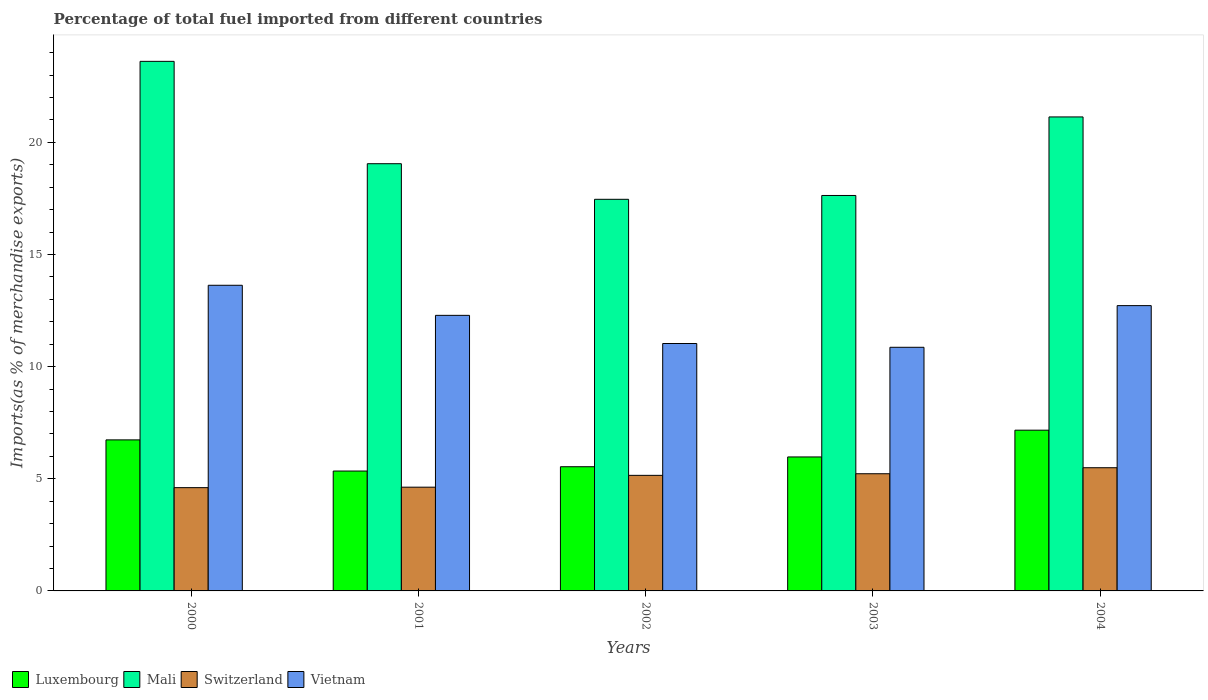How many different coloured bars are there?
Your response must be concise. 4. How many bars are there on the 1st tick from the left?
Give a very brief answer. 4. How many bars are there on the 3rd tick from the right?
Offer a very short reply. 4. What is the label of the 3rd group of bars from the left?
Your answer should be very brief. 2002. What is the percentage of imports to different countries in Vietnam in 2000?
Your answer should be very brief. 13.63. Across all years, what is the maximum percentage of imports to different countries in Vietnam?
Offer a terse response. 13.63. Across all years, what is the minimum percentage of imports to different countries in Vietnam?
Your answer should be compact. 10.86. What is the total percentage of imports to different countries in Switzerland in the graph?
Offer a very short reply. 25.1. What is the difference between the percentage of imports to different countries in Vietnam in 2001 and that in 2004?
Offer a terse response. -0.43. What is the difference between the percentage of imports to different countries in Switzerland in 2000 and the percentage of imports to different countries in Vietnam in 2001?
Ensure brevity in your answer.  -7.68. What is the average percentage of imports to different countries in Switzerland per year?
Provide a succinct answer. 5.02. In the year 2001, what is the difference between the percentage of imports to different countries in Vietnam and percentage of imports to different countries in Switzerland?
Provide a succinct answer. 7.66. What is the ratio of the percentage of imports to different countries in Vietnam in 2002 to that in 2004?
Make the answer very short. 0.87. Is the difference between the percentage of imports to different countries in Vietnam in 2002 and 2003 greater than the difference between the percentage of imports to different countries in Switzerland in 2002 and 2003?
Ensure brevity in your answer.  Yes. What is the difference between the highest and the second highest percentage of imports to different countries in Luxembourg?
Keep it short and to the point. 0.43. What is the difference between the highest and the lowest percentage of imports to different countries in Mali?
Give a very brief answer. 6.15. Is the sum of the percentage of imports to different countries in Switzerland in 2002 and 2003 greater than the maximum percentage of imports to different countries in Mali across all years?
Give a very brief answer. No. Is it the case that in every year, the sum of the percentage of imports to different countries in Vietnam and percentage of imports to different countries in Mali is greater than the sum of percentage of imports to different countries in Luxembourg and percentage of imports to different countries in Switzerland?
Offer a very short reply. Yes. What does the 1st bar from the left in 2000 represents?
Your answer should be compact. Luxembourg. What does the 3rd bar from the right in 2003 represents?
Ensure brevity in your answer.  Mali. Are all the bars in the graph horizontal?
Your answer should be very brief. No. Does the graph contain grids?
Offer a terse response. No. How many legend labels are there?
Make the answer very short. 4. What is the title of the graph?
Make the answer very short. Percentage of total fuel imported from different countries. What is the label or title of the Y-axis?
Provide a short and direct response. Imports(as % of merchandise exports). What is the Imports(as % of merchandise exports) of Luxembourg in 2000?
Provide a short and direct response. 6.73. What is the Imports(as % of merchandise exports) in Mali in 2000?
Provide a succinct answer. 23.61. What is the Imports(as % of merchandise exports) in Switzerland in 2000?
Your answer should be very brief. 4.6. What is the Imports(as % of merchandise exports) of Vietnam in 2000?
Your answer should be compact. 13.63. What is the Imports(as % of merchandise exports) in Luxembourg in 2001?
Offer a very short reply. 5.34. What is the Imports(as % of merchandise exports) of Mali in 2001?
Offer a terse response. 19.05. What is the Imports(as % of merchandise exports) of Switzerland in 2001?
Provide a succinct answer. 4.63. What is the Imports(as % of merchandise exports) in Vietnam in 2001?
Your answer should be compact. 12.29. What is the Imports(as % of merchandise exports) in Luxembourg in 2002?
Your answer should be compact. 5.54. What is the Imports(as % of merchandise exports) of Mali in 2002?
Offer a terse response. 17.46. What is the Imports(as % of merchandise exports) of Switzerland in 2002?
Offer a terse response. 5.15. What is the Imports(as % of merchandise exports) of Vietnam in 2002?
Give a very brief answer. 11.03. What is the Imports(as % of merchandise exports) in Luxembourg in 2003?
Keep it short and to the point. 5.97. What is the Imports(as % of merchandise exports) of Mali in 2003?
Offer a terse response. 17.63. What is the Imports(as % of merchandise exports) in Switzerland in 2003?
Ensure brevity in your answer.  5.22. What is the Imports(as % of merchandise exports) of Vietnam in 2003?
Offer a terse response. 10.86. What is the Imports(as % of merchandise exports) of Luxembourg in 2004?
Your answer should be very brief. 7.17. What is the Imports(as % of merchandise exports) in Mali in 2004?
Your answer should be compact. 21.13. What is the Imports(as % of merchandise exports) in Switzerland in 2004?
Offer a very short reply. 5.49. What is the Imports(as % of merchandise exports) of Vietnam in 2004?
Make the answer very short. 12.72. Across all years, what is the maximum Imports(as % of merchandise exports) in Luxembourg?
Give a very brief answer. 7.17. Across all years, what is the maximum Imports(as % of merchandise exports) of Mali?
Ensure brevity in your answer.  23.61. Across all years, what is the maximum Imports(as % of merchandise exports) of Switzerland?
Your response must be concise. 5.49. Across all years, what is the maximum Imports(as % of merchandise exports) of Vietnam?
Provide a succinct answer. 13.63. Across all years, what is the minimum Imports(as % of merchandise exports) of Luxembourg?
Offer a terse response. 5.34. Across all years, what is the minimum Imports(as % of merchandise exports) of Mali?
Your answer should be compact. 17.46. Across all years, what is the minimum Imports(as % of merchandise exports) of Switzerland?
Give a very brief answer. 4.6. Across all years, what is the minimum Imports(as % of merchandise exports) of Vietnam?
Provide a short and direct response. 10.86. What is the total Imports(as % of merchandise exports) of Luxembourg in the graph?
Your answer should be very brief. 30.76. What is the total Imports(as % of merchandise exports) of Mali in the graph?
Your answer should be very brief. 98.88. What is the total Imports(as % of merchandise exports) of Switzerland in the graph?
Your answer should be very brief. 25.1. What is the total Imports(as % of merchandise exports) in Vietnam in the graph?
Your answer should be very brief. 60.53. What is the difference between the Imports(as % of merchandise exports) in Luxembourg in 2000 and that in 2001?
Your answer should be very brief. 1.39. What is the difference between the Imports(as % of merchandise exports) of Mali in 2000 and that in 2001?
Provide a short and direct response. 4.56. What is the difference between the Imports(as % of merchandise exports) of Switzerland in 2000 and that in 2001?
Your answer should be compact. -0.02. What is the difference between the Imports(as % of merchandise exports) in Vietnam in 2000 and that in 2001?
Ensure brevity in your answer.  1.34. What is the difference between the Imports(as % of merchandise exports) in Luxembourg in 2000 and that in 2002?
Offer a very short reply. 1.2. What is the difference between the Imports(as % of merchandise exports) in Mali in 2000 and that in 2002?
Give a very brief answer. 6.15. What is the difference between the Imports(as % of merchandise exports) in Switzerland in 2000 and that in 2002?
Keep it short and to the point. -0.55. What is the difference between the Imports(as % of merchandise exports) of Vietnam in 2000 and that in 2002?
Make the answer very short. 2.6. What is the difference between the Imports(as % of merchandise exports) in Luxembourg in 2000 and that in 2003?
Keep it short and to the point. 0.76. What is the difference between the Imports(as % of merchandise exports) of Mali in 2000 and that in 2003?
Your response must be concise. 5.98. What is the difference between the Imports(as % of merchandise exports) of Switzerland in 2000 and that in 2003?
Provide a succinct answer. -0.62. What is the difference between the Imports(as % of merchandise exports) of Vietnam in 2000 and that in 2003?
Provide a short and direct response. 2.76. What is the difference between the Imports(as % of merchandise exports) in Luxembourg in 2000 and that in 2004?
Keep it short and to the point. -0.43. What is the difference between the Imports(as % of merchandise exports) in Mali in 2000 and that in 2004?
Your response must be concise. 2.48. What is the difference between the Imports(as % of merchandise exports) of Switzerland in 2000 and that in 2004?
Your answer should be very brief. -0.89. What is the difference between the Imports(as % of merchandise exports) in Vietnam in 2000 and that in 2004?
Your response must be concise. 0.91. What is the difference between the Imports(as % of merchandise exports) in Luxembourg in 2001 and that in 2002?
Offer a terse response. -0.19. What is the difference between the Imports(as % of merchandise exports) of Mali in 2001 and that in 2002?
Provide a succinct answer. 1.59. What is the difference between the Imports(as % of merchandise exports) of Switzerland in 2001 and that in 2002?
Offer a very short reply. -0.53. What is the difference between the Imports(as % of merchandise exports) of Vietnam in 2001 and that in 2002?
Your response must be concise. 1.26. What is the difference between the Imports(as % of merchandise exports) of Luxembourg in 2001 and that in 2003?
Your response must be concise. -0.63. What is the difference between the Imports(as % of merchandise exports) in Mali in 2001 and that in 2003?
Provide a succinct answer. 1.42. What is the difference between the Imports(as % of merchandise exports) of Switzerland in 2001 and that in 2003?
Make the answer very short. -0.6. What is the difference between the Imports(as % of merchandise exports) in Vietnam in 2001 and that in 2003?
Provide a short and direct response. 1.42. What is the difference between the Imports(as % of merchandise exports) in Luxembourg in 2001 and that in 2004?
Your response must be concise. -1.82. What is the difference between the Imports(as % of merchandise exports) in Mali in 2001 and that in 2004?
Provide a short and direct response. -2.09. What is the difference between the Imports(as % of merchandise exports) of Switzerland in 2001 and that in 2004?
Offer a terse response. -0.87. What is the difference between the Imports(as % of merchandise exports) in Vietnam in 2001 and that in 2004?
Keep it short and to the point. -0.43. What is the difference between the Imports(as % of merchandise exports) in Luxembourg in 2002 and that in 2003?
Give a very brief answer. -0.44. What is the difference between the Imports(as % of merchandise exports) in Mali in 2002 and that in 2003?
Your response must be concise. -0.17. What is the difference between the Imports(as % of merchandise exports) of Switzerland in 2002 and that in 2003?
Offer a terse response. -0.07. What is the difference between the Imports(as % of merchandise exports) of Vietnam in 2002 and that in 2003?
Your response must be concise. 0.17. What is the difference between the Imports(as % of merchandise exports) of Luxembourg in 2002 and that in 2004?
Offer a very short reply. -1.63. What is the difference between the Imports(as % of merchandise exports) in Mali in 2002 and that in 2004?
Ensure brevity in your answer.  -3.67. What is the difference between the Imports(as % of merchandise exports) of Switzerland in 2002 and that in 2004?
Your answer should be compact. -0.34. What is the difference between the Imports(as % of merchandise exports) of Vietnam in 2002 and that in 2004?
Give a very brief answer. -1.69. What is the difference between the Imports(as % of merchandise exports) of Luxembourg in 2003 and that in 2004?
Provide a short and direct response. -1.19. What is the difference between the Imports(as % of merchandise exports) of Mali in 2003 and that in 2004?
Offer a very short reply. -3.5. What is the difference between the Imports(as % of merchandise exports) in Switzerland in 2003 and that in 2004?
Provide a succinct answer. -0.27. What is the difference between the Imports(as % of merchandise exports) of Vietnam in 2003 and that in 2004?
Offer a very short reply. -1.86. What is the difference between the Imports(as % of merchandise exports) of Luxembourg in 2000 and the Imports(as % of merchandise exports) of Mali in 2001?
Provide a short and direct response. -12.31. What is the difference between the Imports(as % of merchandise exports) of Luxembourg in 2000 and the Imports(as % of merchandise exports) of Switzerland in 2001?
Your answer should be very brief. 2.11. What is the difference between the Imports(as % of merchandise exports) in Luxembourg in 2000 and the Imports(as % of merchandise exports) in Vietnam in 2001?
Provide a succinct answer. -5.55. What is the difference between the Imports(as % of merchandise exports) in Mali in 2000 and the Imports(as % of merchandise exports) in Switzerland in 2001?
Offer a very short reply. 18.99. What is the difference between the Imports(as % of merchandise exports) of Mali in 2000 and the Imports(as % of merchandise exports) of Vietnam in 2001?
Make the answer very short. 11.32. What is the difference between the Imports(as % of merchandise exports) in Switzerland in 2000 and the Imports(as % of merchandise exports) in Vietnam in 2001?
Make the answer very short. -7.68. What is the difference between the Imports(as % of merchandise exports) of Luxembourg in 2000 and the Imports(as % of merchandise exports) of Mali in 2002?
Make the answer very short. -10.73. What is the difference between the Imports(as % of merchandise exports) in Luxembourg in 2000 and the Imports(as % of merchandise exports) in Switzerland in 2002?
Provide a succinct answer. 1.58. What is the difference between the Imports(as % of merchandise exports) of Luxembourg in 2000 and the Imports(as % of merchandise exports) of Vietnam in 2002?
Make the answer very short. -4.3. What is the difference between the Imports(as % of merchandise exports) of Mali in 2000 and the Imports(as % of merchandise exports) of Switzerland in 2002?
Keep it short and to the point. 18.46. What is the difference between the Imports(as % of merchandise exports) in Mali in 2000 and the Imports(as % of merchandise exports) in Vietnam in 2002?
Provide a short and direct response. 12.58. What is the difference between the Imports(as % of merchandise exports) of Switzerland in 2000 and the Imports(as % of merchandise exports) of Vietnam in 2002?
Provide a succinct answer. -6.43. What is the difference between the Imports(as % of merchandise exports) of Luxembourg in 2000 and the Imports(as % of merchandise exports) of Mali in 2003?
Your answer should be very brief. -10.9. What is the difference between the Imports(as % of merchandise exports) in Luxembourg in 2000 and the Imports(as % of merchandise exports) in Switzerland in 2003?
Provide a short and direct response. 1.51. What is the difference between the Imports(as % of merchandise exports) in Luxembourg in 2000 and the Imports(as % of merchandise exports) in Vietnam in 2003?
Make the answer very short. -4.13. What is the difference between the Imports(as % of merchandise exports) of Mali in 2000 and the Imports(as % of merchandise exports) of Switzerland in 2003?
Your response must be concise. 18.39. What is the difference between the Imports(as % of merchandise exports) in Mali in 2000 and the Imports(as % of merchandise exports) in Vietnam in 2003?
Ensure brevity in your answer.  12.75. What is the difference between the Imports(as % of merchandise exports) of Switzerland in 2000 and the Imports(as % of merchandise exports) of Vietnam in 2003?
Your response must be concise. -6.26. What is the difference between the Imports(as % of merchandise exports) in Luxembourg in 2000 and the Imports(as % of merchandise exports) in Mali in 2004?
Your answer should be very brief. -14.4. What is the difference between the Imports(as % of merchandise exports) of Luxembourg in 2000 and the Imports(as % of merchandise exports) of Switzerland in 2004?
Ensure brevity in your answer.  1.24. What is the difference between the Imports(as % of merchandise exports) of Luxembourg in 2000 and the Imports(as % of merchandise exports) of Vietnam in 2004?
Offer a very short reply. -5.99. What is the difference between the Imports(as % of merchandise exports) in Mali in 2000 and the Imports(as % of merchandise exports) in Switzerland in 2004?
Keep it short and to the point. 18.12. What is the difference between the Imports(as % of merchandise exports) of Mali in 2000 and the Imports(as % of merchandise exports) of Vietnam in 2004?
Your answer should be very brief. 10.89. What is the difference between the Imports(as % of merchandise exports) of Switzerland in 2000 and the Imports(as % of merchandise exports) of Vietnam in 2004?
Offer a very short reply. -8.12. What is the difference between the Imports(as % of merchandise exports) of Luxembourg in 2001 and the Imports(as % of merchandise exports) of Mali in 2002?
Offer a terse response. -12.12. What is the difference between the Imports(as % of merchandise exports) in Luxembourg in 2001 and the Imports(as % of merchandise exports) in Switzerland in 2002?
Provide a short and direct response. 0.19. What is the difference between the Imports(as % of merchandise exports) of Luxembourg in 2001 and the Imports(as % of merchandise exports) of Vietnam in 2002?
Your answer should be very brief. -5.69. What is the difference between the Imports(as % of merchandise exports) in Mali in 2001 and the Imports(as % of merchandise exports) in Switzerland in 2002?
Your answer should be compact. 13.89. What is the difference between the Imports(as % of merchandise exports) of Mali in 2001 and the Imports(as % of merchandise exports) of Vietnam in 2002?
Provide a short and direct response. 8.02. What is the difference between the Imports(as % of merchandise exports) of Switzerland in 2001 and the Imports(as % of merchandise exports) of Vietnam in 2002?
Make the answer very short. -6.41. What is the difference between the Imports(as % of merchandise exports) in Luxembourg in 2001 and the Imports(as % of merchandise exports) in Mali in 2003?
Offer a terse response. -12.29. What is the difference between the Imports(as % of merchandise exports) of Luxembourg in 2001 and the Imports(as % of merchandise exports) of Switzerland in 2003?
Ensure brevity in your answer.  0.12. What is the difference between the Imports(as % of merchandise exports) in Luxembourg in 2001 and the Imports(as % of merchandise exports) in Vietnam in 2003?
Keep it short and to the point. -5.52. What is the difference between the Imports(as % of merchandise exports) in Mali in 2001 and the Imports(as % of merchandise exports) in Switzerland in 2003?
Provide a short and direct response. 13.82. What is the difference between the Imports(as % of merchandise exports) of Mali in 2001 and the Imports(as % of merchandise exports) of Vietnam in 2003?
Your response must be concise. 8.18. What is the difference between the Imports(as % of merchandise exports) of Switzerland in 2001 and the Imports(as % of merchandise exports) of Vietnam in 2003?
Offer a very short reply. -6.24. What is the difference between the Imports(as % of merchandise exports) in Luxembourg in 2001 and the Imports(as % of merchandise exports) in Mali in 2004?
Your answer should be compact. -15.79. What is the difference between the Imports(as % of merchandise exports) of Luxembourg in 2001 and the Imports(as % of merchandise exports) of Switzerland in 2004?
Offer a very short reply. -0.15. What is the difference between the Imports(as % of merchandise exports) in Luxembourg in 2001 and the Imports(as % of merchandise exports) in Vietnam in 2004?
Keep it short and to the point. -7.38. What is the difference between the Imports(as % of merchandise exports) in Mali in 2001 and the Imports(as % of merchandise exports) in Switzerland in 2004?
Make the answer very short. 13.55. What is the difference between the Imports(as % of merchandise exports) of Mali in 2001 and the Imports(as % of merchandise exports) of Vietnam in 2004?
Give a very brief answer. 6.33. What is the difference between the Imports(as % of merchandise exports) in Switzerland in 2001 and the Imports(as % of merchandise exports) in Vietnam in 2004?
Provide a succinct answer. -8.09. What is the difference between the Imports(as % of merchandise exports) in Luxembourg in 2002 and the Imports(as % of merchandise exports) in Mali in 2003?
Make the answer very short. -12.09. What is the difference between the Imports(as % of merchandise exports) in Luxembourg in 2002 and the Imports(as % of merchandise exports) in Switzerland in 2003?
Provide a succinct answer. 0.31. What is the difference between the Imports(as % of merchandise exports) of Luxembourg in 2002 and the Imports(as % of merchandise exports) of Vietnam in 2003?
Ensure brevity in your answer.  -5.33. What is the difference between the Imports(as % of merchandise exports) of Mali in 2002 and the Imports(as % of merchandise exports) of Switzerland in 2003?
Keep it short and to the point. 12.24. What is the difference between the Imports(as % of merchandise exports) in Mali in 2002 and the Imports(as % of merchandise exports) in Vietnam in 2003?
Your response must be concise. 6.6. What is the difference between the Imports(as % of merchandise exports) in Switzerland in 2002 and the Imports(as % of merchandise exports) in Vietnam in 2003?
Provide a short and direct response. -5.71. What is the difference between the Imports(as % of merchandise exports) in Luxembourg in 2002 and the Imports(as % of merchandise exports) in Mali in 2004?
Give a very brief answer. -15.6. What is the difference between the Imports(as % of merchandise exports) of Luxembourg in 2002 and the Imports(as % of merchandise exports) of Switzerland in 2004?
Your answer should be compact. 0.04. What is the difference between the Imports(as % of merchandise exports) of Luxembourg in 2002 and the Imports(as % of merchandise exports) of Vietnam in 2004?
Offer a terse response. -7.18. What is the difference between the Imports(as % of merchandise exports) of Mali in 2002 and the Imports(as % of merchandise exports) of Switzerland in 2004?
Provide a succinct answer. 11.97. What is the difference between the Imports(as % of merchandise exports) in Mali in 2002 and the Imports(as % of merchandise exports) in Vietnam in 2004?
Your response must be concise. 4.74. What is the difference between the Imports(as % of merchandise exports) of Switzerland in 2002 and the Imports(as % of merchandise exports) of Vietnam in 2004?
Offer a terse response. -7.57. What is the difference between the Imports(as % of merchandise exports) in Luxembourg in 2003 and the Imports(as % of merchandise exports) in Mali in 2004?
Provide a succinct answer. -15.16. What is the difference between the Imports(as % of merchandise exports) in Luxembourg in 2003 and the Imports(as % of merchandise exports) in Switzerland in 2004?
Make the answer very short. 0.48. What is the difference between the Imports(as % of merchandise exports) of Luxembourg in 2003 and the Imports(as % of merchandise exports) of Vietnam in 2004?
Provide a succinct answer. -6.75. What is the difference between the Imports(as % of merchandise exports) in Mali in 2003 and the Imports(as % of merchandise exports) in Switzerland in 2004?
Ensure brevity in your answer.  12.14. What is the difference between the Imports(as % of merchandise exports) in Mali in 2003 and the Imports(as % of merchandise exports) in Vietnam in 2004?
Your answer should be compact. 4.91. What is the difference between the Imports(as % of merchandise exports) of Switzerland in 2003 and the Imports(as % of merchandise exports) of Vietnam in 2004?
Your response must be concise. -7.5. What is the average Imports(as % of merchandise exports) in Luxembourg per year?
Your answer should be very brief. 6.15. What is the average Imports(as % of merchandise exports) in Mali per year?
Your answer should be very brief. 19.78. What is the average Imports(as % of merchandise exports) of Switzerland per year?
Give a very brief answer. 5.02. What is the average Imports(as % of merchandise exports) of Vietnam per year?
Provide a succinct answer. 12.11. In the year 2000, what is the difference between the Imports(as % of merchandise exports) in Luxembourg and Imports(as % of merchandise exports) in Mali?
Your answer should be compact. -16.88. In the year 2000, what is the difference between the Imports(as % of merchandise exports) in Luxembourg and Imports(as % of merchandise exports) in Switzerland?
Give a very brief answer. 2.13. In the year 2000, what is the difference between the Imports(as % of merchandise exports) of Luxembourg and Imports(as % of merchandise exports) of Vietnam?
Give a very brief answer. -6.89. In the year 2000, what is the difference between the Imports(as % of merchandise exports) in Mali and Imports(as % of merchandise exports) in Switzerland?
Give a very brief answer. 19.01. In the year 2000, what is the difference between the Imports(as % of merchandise exports) in Mali and Imports(as % of merchandise exports) in Vietnam?
Keep it short and to the point. 9.98. In the year 2000, what is the difference between the Imports(as % of merchandise exports) in Switzerland and Imports(as % of merchandise exports) in Vietnam?
Give a very brief answer. -9.02. In the year 2001, what is the difference between the Imports(as % of merchandise exports) in Luxembourg and Imports(as % of merchandise exports) in Mali?
Provide a succinct answer. -13.7. In the year 2001, what is the difference between the Imports(as % of merchandise exports) of Luxembourg and Imports(as % of merchandise exports) of Switzerland?
Provide a succinct answer. 0.72. In the year 2001, what is the difference between the Imports(as % of merchandise exports) in Luxembourg and Imports(as % of merchandise exports) in Vietnam?
Make the answer very short. -6.94. In the year 2001, what is the difference between the Imports(as % of merchandise exports) in Mali and Imports(as % of merchandise exports) in Switzerland?
Provide a short and direct response. 14.42. In the year 2001, what is the difference between the Imports(as % of merchandise exports) of Mali and Imports(as % of merchandise exports) of Vietnam?
Ensure brevity in your answer.  6.76. In the year 2001, what is the difference between the Imports(as % of merchandise exports) in Switzerland and Imports(as % of merchandise exports) in Vietnam?
Provide a short and direct response. -7.66. In the year 2002, what is the difference between the Imports(as % of merchandise exports) in Luxembourg and Imports(as % of merchandise exports) in Mali?
Provide a short and direct response. -11.92. In the year 2002, what is the difference between the Imports(as % of merchandise exports) of Luxembourg and Imports(as % of merchandise exports) of Switzerland?
Your response must be concise. 0.38. In the year 2002, what is the difference between the Imports(as % of merchandise exports) in Luxembourg and Imports(as % of merchandise exports) in Vietnam?
Your answer should be compact. -5.49. In the year 2002, what is the difference between the Imports(as % of merchandise exports) in Mali and Imports(as % of merchandise exports) in Switzerland?
Your response must be concise. 12.31. In the year 2002, what is the difference between the Imports(as % of merchandise exports) of Mali and Imports(as % of merchandise exports) of Vietnam?
Ensure brevity in your answer.  6.43. In the year 2002, what is the difference between the Imports(as % of merchandise exports) of Switzerland and Imports(as % of merchandise exports) of Vietnam?
Your response must be concise. -5.88. In the year 2003, what is the difference between the Imports(as % of merchandise exports) in Luxembourg and Imports(as % of merchandise exports) in Mali?
Keep it short and to the point. -11.66. In the year 2003, what is the difference between the Imports(as % of merchandise exports) in Luxembourg and Imports(as % of merchandise exports) in Switzerland?
Keep it short and to the point. 0.75. In the year 2003, what is the difference between the Imports(as % of merchandise exports) of Luxembourg and Imports(as % of merchandise exports) of Vietnam?
Give a very brief answer. -4.89. In the year 2003, what is the difference between the Imports(as % of merchandise exports) in Mali and Imports(as % of merchandise exports) in Switzerland?
Your answer should be compact. 12.41. In the year 2003, what is the difference between the Imports(as % of merchandise exports) in Mali and Imports(as % of merchandise exports) in Vietnam?
Make the answer very short. 6.77. In the year 2003, what is the difference between the Imports(as % of merchandise exports) in Switzerland and Imports(as % of merchandise exports) in Vietnam?
Give a very brief answer. -5.64. In the year 2004, what is the difference between the Imports(as % of merchandise exports) of Luxembourg and Imports(as % of merchandise exports) of Mali?
Offer a very short reply. -13.97. In the year 2004, what is the difference between the Imports(as % of merchandise exports) in Luxembourg and Imports(as % of merchandise exports) in Switzerland?
Provide a succinct answer. 1.67. In the year 2004, what is the difference between the Imports(as % of merchandise exports) in Luxembourg and Imports(as % of merchandise exports) in Vietnam?
Provide a succinct answer. -5.55. In the year 2004, what is the difference between the Imports(as % of merchandise exports) in Mali and Imports(as % of merchandise exports) in Switzerland?
Provide a short and direct response. 15.64. In the year 2004, what is the difference between the Imports(as % of merchandise exports) in Mali and Imports(as % of merchandise exports) in Vietnam?
Keep it short and to the point. 8.41. In the year 2004, what is the difference between the Imports(as % of merchandise exports) of Switzerland and Imports(as % of merchandise exports) of Vietnam?
Offer a terse response. -7.23. What is the ratio of the Imports(as % of merchandise exports) in Luxembourg in 2000 to that in 2001?
Your response must be concise. 1.26. What is the ratio of the Imports(as % of merchandise exports) in Mali in 2000 to that in 2001?
Your answer should be very brief. 1.24. What is the ratio of the Imports(as % of merchandise exports) of Switzerland in 2000 to that in 2001?
Provide a succinct answer. 1. What is the ratio of the Imports(as % of merchandise exports) in Vietnam in 2000 to that in 2001?
Offer a very short reply. 1.11. What is the ratio of the Imports(as % of merchandise exports) in Luxembourg in 2000 to that in 2002?
Ensure brevity in your answer.  1.22. What is the ratio of the Imports(as % of merchandise exports) of Mali in 2000 to that in 2002?
Offer a very short reply. 1.35. What is the ratio of the Imports(as % of merchandise exports) in Switzerland in 2000 to that in 2002?
Your answer should be very brief. 0.89. What is the ratio of the Imports(as % of merchandise exports) of Vietnam in 2000 to that in 2002?
Your response must be concise. 1.24. What is the ratio of the Imports(as % of merchandise exports) of Luxembourg in 2000 to that in 2003?
Provide a short and direct response. 1.13. What is the ratio of the Imports(as % of merchandise exports) of Mali in 2000 to that in 2003?
Your answer should be very brief. 1.34. What is the ratio of the Imports(as % of merchandise exports) of Switzerland in 2000 to that in 2003?
Your answer should be compact. 0.88. What is the ratio of the Imports(as % of merchandise exports) in Vietnam in 2000 to that in 2003?
Provide a succinct answer. 1.25. What is the ratio of the Imports(as % of merchandise exports) of Luxembourg in 2000 to that in 2004?
Give a very brief answer. 0.94. What is the ratio of the Imports(as % of merchandise exports) of Mali in 2000 to that in 2004?
Your answer should be very brief. 1.12. What is the ratio of the Imports(as % of merchandise exports) in Switzerland in 2000 to that in 2004?
Your answer should be very brief. 0.84. What is the ratio of the Imports(as % of merchandise exports) of Vietnam in 2000 to that in 2004?
Provide a short and direct response. 1.07. What is the ratio of the Imports(as % of merchandise exports) of Luxembourg in 2001 to that in 2002?
Provide a succinct answer. 0.97. What is the ratio of the Imports(as % of merchandise exports) of Mali in 2001 to that in 2002?
Offer a very short reply. 1.09. What is the ratio of the Imports(as % of merchandise exports) of Switzerland in 2001 to that in 2002?
Make the answer very short. 0.9. What is the ratio of the Imports(as % of merchandise exports) of Vietnam in 2001 to that in 2002?
Give a very brief answer. 1.11. What is the ratio of the Imports(as % of merchandise exports) of Luxembourg in 2001 to that in 2003?
Keep it short and to the point. 0.89. What is the ratio of the Imports(as % of merchandise exports) in Mali in 2001 to that in 2003?
Make the answer very short. 1.08. What is the ratio of the Imports(as % of merchandise exports) in Switzerland in 2001 to that in 2003?
Make the answer very short. 0.89. What is the ratio of the Imports(as % of merchandise exports) of Vietnam in 2001 to that in 2003?
Provide a short and direct response. 1.13. What is the ratio of the Imports(as % of merchandise exports) in Luxembourg in 2001 to that in 2004?
Provide a succinct answer. 0.75. What is the ratio of the Imports(as % of merchandise exports) of Mali in 2001 to that in 2004?
Your answer should be compact. 0.9. What is the ratio of the Imports(as % of merchandise exports) of Switzerland in 2001 to that in 2004?
Your answer should be compact. 0.84. What is the ratio of the Imports(as % of merchandise exports) of Vietnam in 2001 to that in 2004?
Keep it short and to the point. 0.97. What is the ratio of the Imports(as % of merchandise exports) in Luxembourg in 2002 to that in 2003?
Provide a short and direct response. 0.93. What is the ratio of the Imports(as % of merchandise exports) of Mali in 2002 to that in 2003?
Offer a terse response. 0.99. What is the ratio of the Imports(as % of merchandise exports) of Switzerland in 2002 to that in 2003?
Your answer should be very brief. 0.99. What is the ratio of the Imports(as % of merchandise exports) in Vietnam in 2002 to that in 2003?
Provide a succinct answer. 1.02. What is the ratio of the Imports(as % of merchandise exports) in Luxembourg in 2002 to that in 2004?
Provide a short and direct response. 0.77. What is the ratio of the Imports(as % of merchandise exports) in Mali in 2002 to that in 2004?
Your answer should be very brief. 0.83. What is the ratio of the Imports(as % of merchandise exports) in Switzerland in 2002 to that in 2004?
Offer a very short reply. 0.94. What is the ratio of the Imports(as % of merchandise exports) in Vietnam in 2002 to that in 2004?
Give a very brief answer. 0.87. What is the ratio of the Imports(as % of merchandise exports) in Luxembourg in 2003 to that in 2004?
Give a very brief answer. 0.83. What is the ratio of the Imports(as % of merchandise exports) in Mali in 2003 to that in 2004?
Your answer should be compact. 0.83. What is the ratio of the Imports(as % of merchandise exports) in Switzerland in 2003 to that in 2004?
Offer a very short reply. 0.95. What is the ratio of the Imports(as % of merchandise exports) of Vietnam in 2003 to that in 2004?
Offer a very short reply. 0.85. What is the difference between the highest and the second highest Imports(as % of merchandise exports) of Luxembourg?
Your answer should be compact. 0.43. What is the difference between the highest and the second highest Imports(as % of merchandise exports) of Mali?
Give a very brief answer. 2.48. What is the difference between the highest and the second highest Imports(as % of merchandise exports) in Switzerland?
Give a very brief answer. 0.27. What is the difference between the highest and the second highest Imports(as % of merchandise exports) of Vietnam?
Your answer should be compact. 0.91. What is the difference between the highest and the lowest Imports(as % of merchandise exports) of Luxembourg?
Your response must be concise. 1.82. What is the difference between the highest and the lowest Imports(as % of merchandise exports) in Mali?
Provide a succinct answer. 6.15. What is the difference between the highest and the lowest Imports(as % of merchandise exports) of Switzerland?
Make the answer very short. 0.89. What is the difference between the highest and the lowest Imports(as % of merchandise exports) in Vietnam?
Make the answer very short. 2.76. 